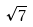<formula> <loc_0><loc_0><loc_500><loc_500>\sqrt { 7 }</formula> 